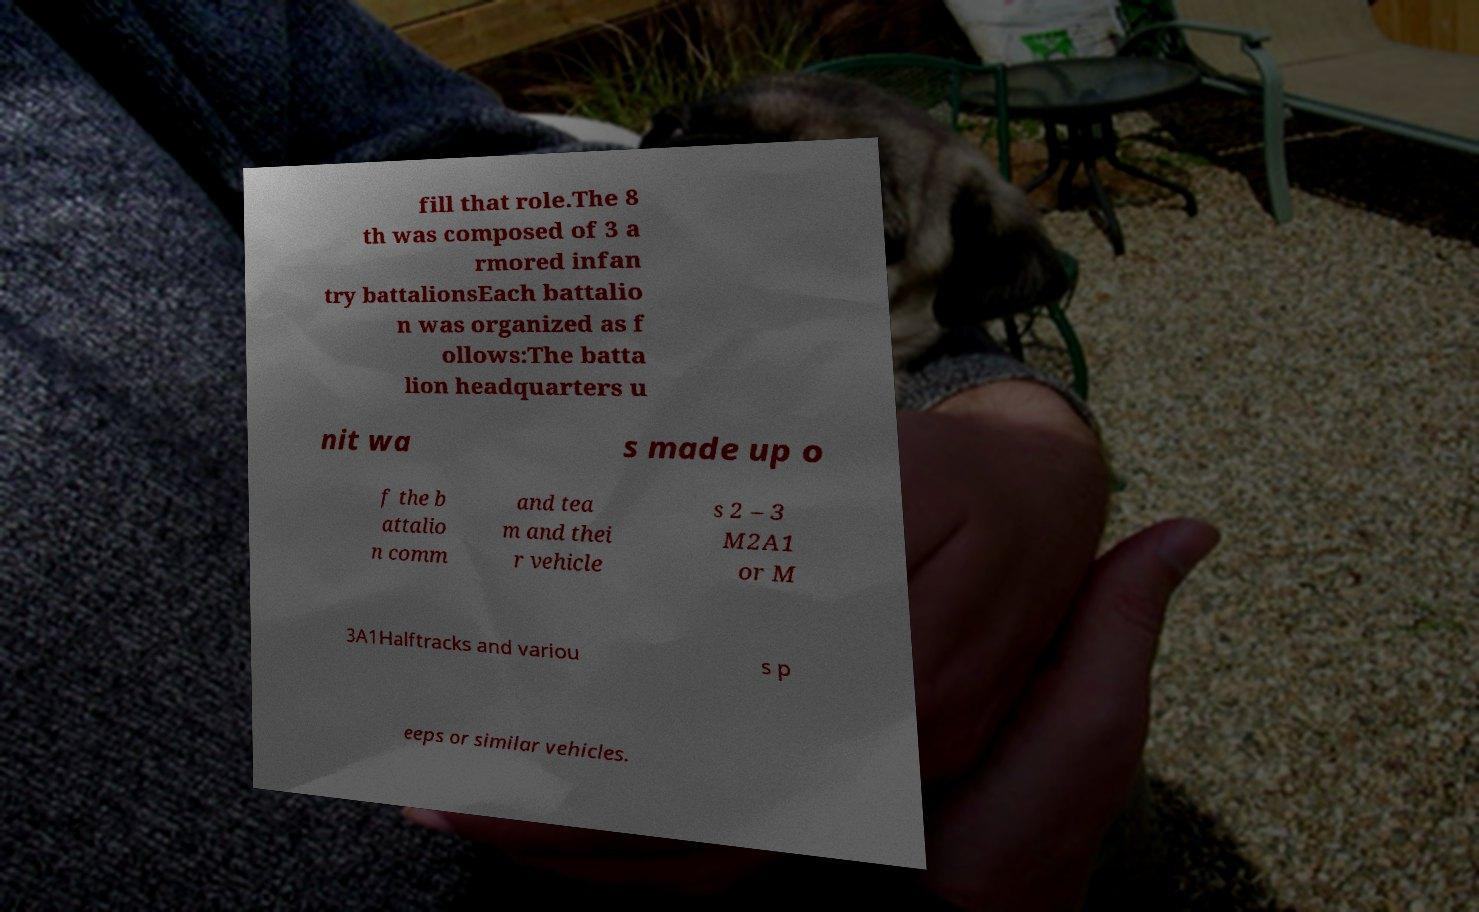What messages or text are displayed in this image? I need them in a readable, typed format. fill that role.The 8 th was composed of 3 a rmored infan try battalionsEach battalio n was organized as f ollows:The batta lion headquarters u nit wa s made up o f the b attalio n comm and tea m and thei r vehicle s 2 – 3 M2A1 or M 3A1Halftracks and variou s p eeps or similar vehicles. 